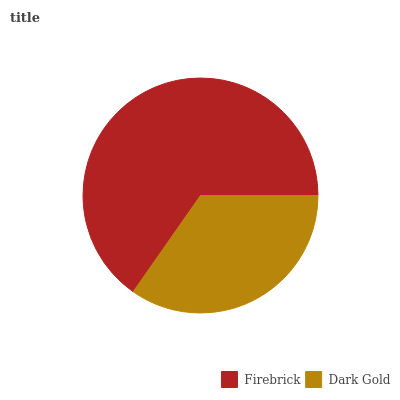Is Dark Gold the minimum?
Answer yes or no. Yes. Is Firebrick the maximum?
Answer yes or no. Yes. Is Dark Gold the maximum?
Answer yes or no. No. Is Firebrick greater than Dark Gold?
Answer yes or no. Yes. Is Dark Gold less than Firebrick?
Answer yes or no. Yes. Is Dark Gold greater than Firebrick?
Answer yes or no. No. Is Firebrick less than Dark Gold?
Answer yes or no. No. Is Firebrick the high median?
Answer yes or no. Yes. Is Dark Gold the low median?
Answer yes or no. Yes. Is Dark Gold the high median?
Answer yes or no. No. Is Firebrick the low median?
Answer yes or no. No. 